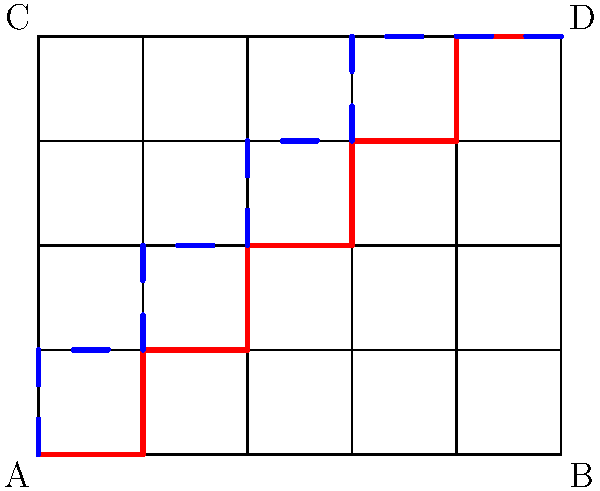In your grow room, you've set up a grid system for organizing cannabis plants. The room is represented by a 4x5 grid, where each intersection point could potentially house a plant. You want to create a path from corner A to corner D that maximizes light exposure and air circulation.

Two potential paths are shown: a red solid path and a blue dashed path. Which path is optimal for plant growth, and why? Consider that each turn in the path represents a potential obstruction to airflow and light distribution. Let's analyze both paths step-by-step:

1. Path properties:
   - Red path: 5 turns, length = 9 units
   - Blue path: 4 turns, length = 9 units

2. Light exposure:
   Both paths have the same length, so they provide equal opportunities for light exposure.

3. Air circulation:
   Turns in the path can obstruct airflow. The blue path has fewer turns (4) compared to the red path (5), allowing for better air circulation.

4. Plant spacing:
   Both paths provide similar spacing between plants, as they both use 9 grid points.

5. Overall layout:
   The blue path creates a more uniform distribution of plants across the grow room, which can lead to more consistent growing conditions.

6. Accessibility:
   The blue path leaves more open space in the center of the room, potentially making it easier to access and maintain plants.

Given these factors, the blue path is optimal for plant growth. It provides the same light exposure opportunity as the red path but offers better air circulation due to fewer turns. Additionally, it creates a more uniform distribution of plants and better accessibility for maintenance.
Answer: Blue path; fewer turns (4 vs 5) for better airflow, equal length for light exposure, more uniform distribution. 